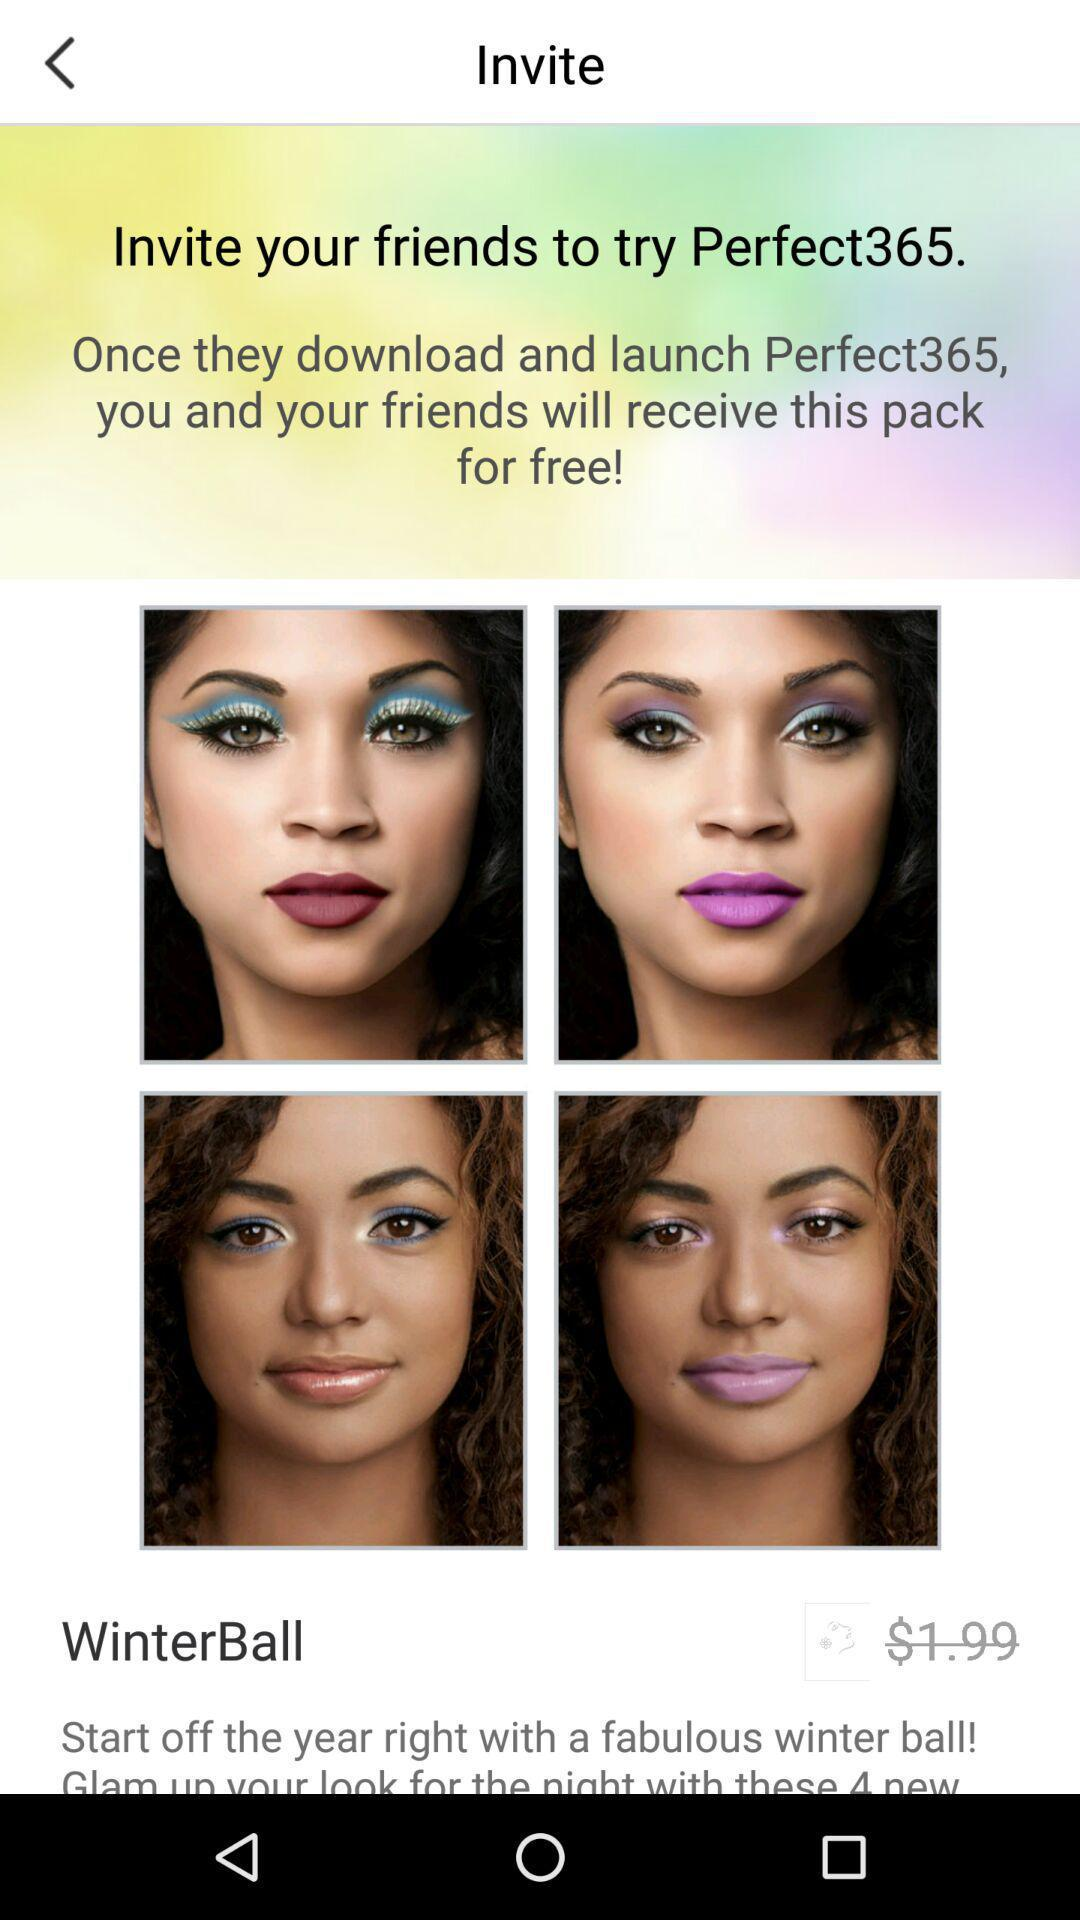What app should be downloaded so that we and our friends will receive the packs for free? The app is "Perfect365". 